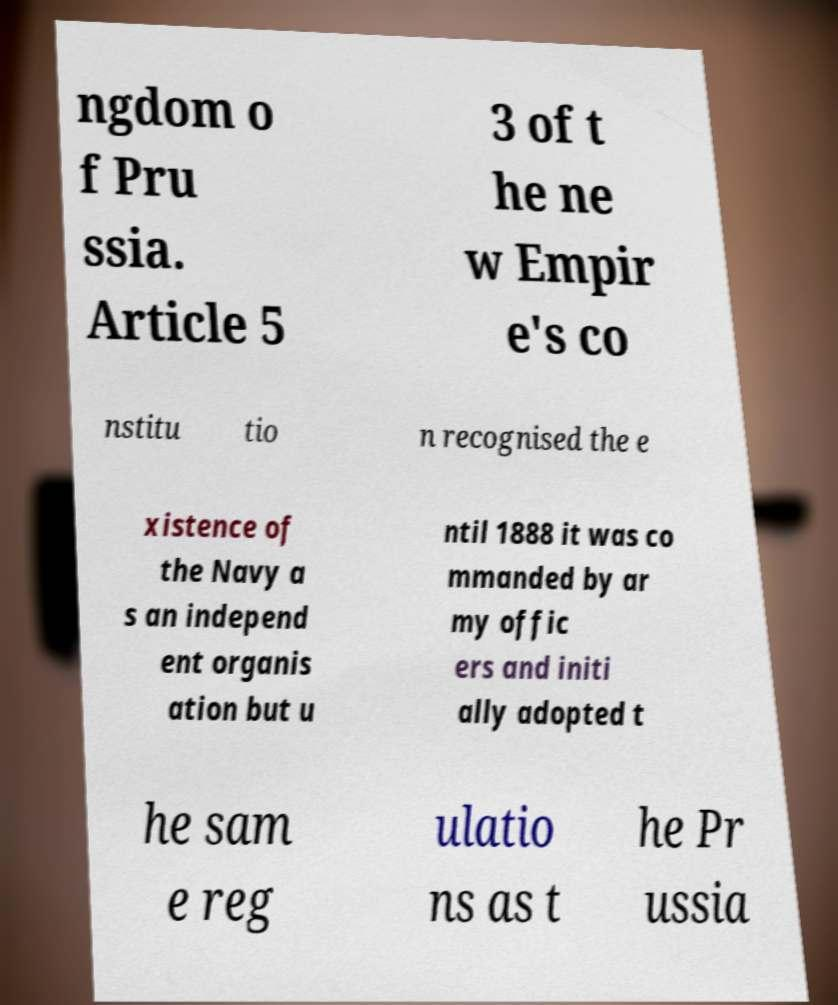Please identify and transcribe the text found in this image. ngdom o f Pru ssia. Article 5 3 of t he ne w Empir e's co nstitu tio n recognised the e xistence of the Navy a s an independ ent organis ation but u ntil 1888 it was co mmanded by ar my offic ers and initi ally adopted t he sam e reg ulatio ns as t he Pr ussia 